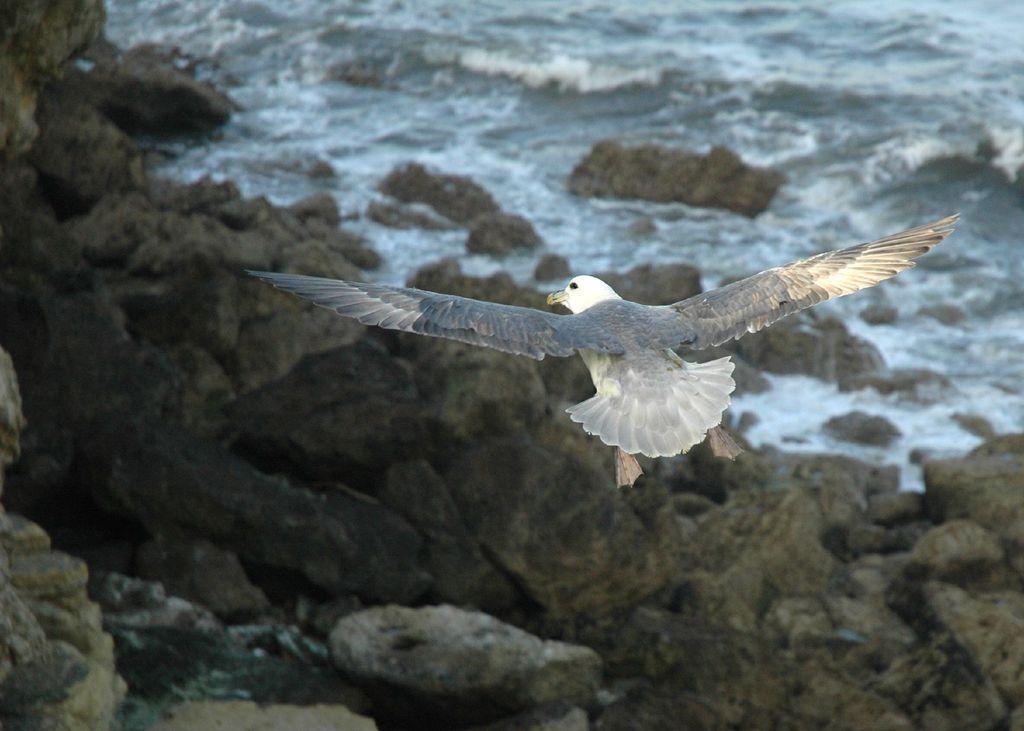In one or two sentences, can you explain what this image depicts? In the foreground of this image, there is a bird in the air. In the background, there are rocks and the water. 